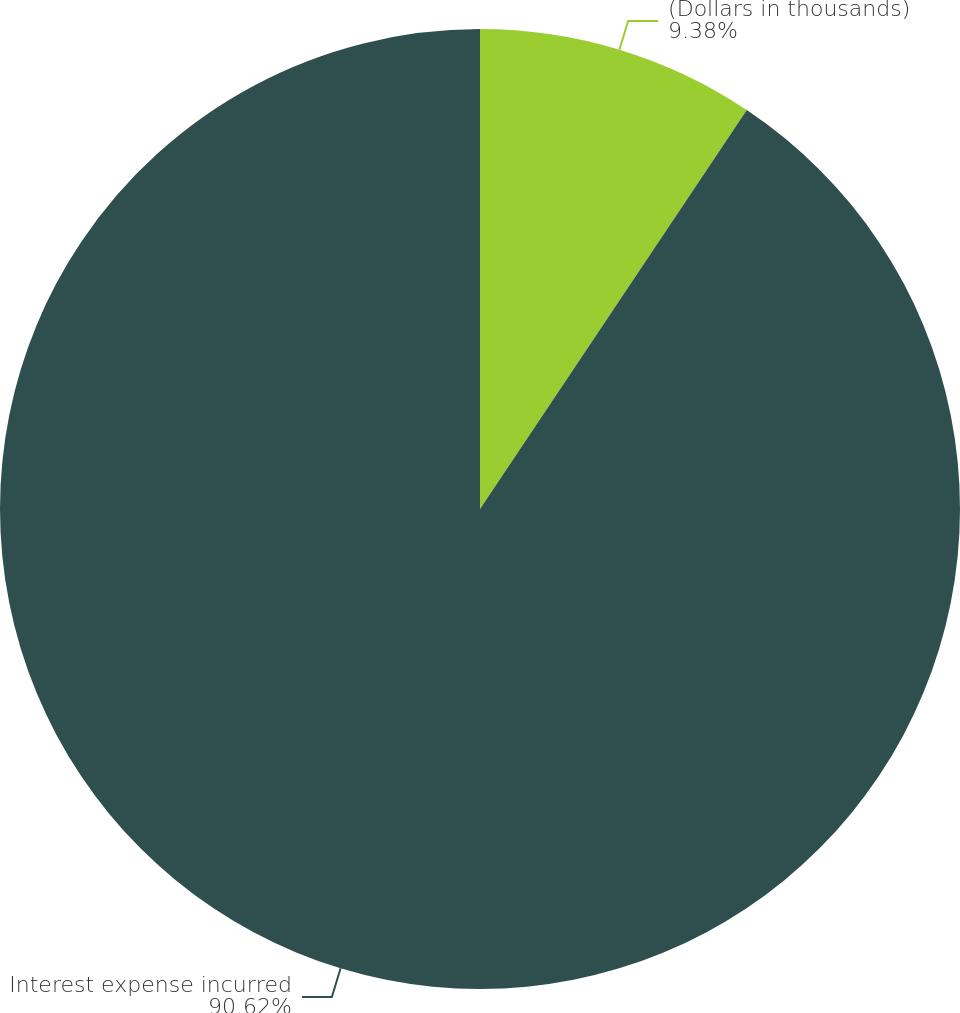Convert chart to OTSL. <chart><loc_0><loc_0><loc_500><loc_500><pie_chart><fcel>(Dollars in thousands)<fcel>Interest expense incurred<nl><fcel>9.38%<fcel>90.62%<nl></chart> 